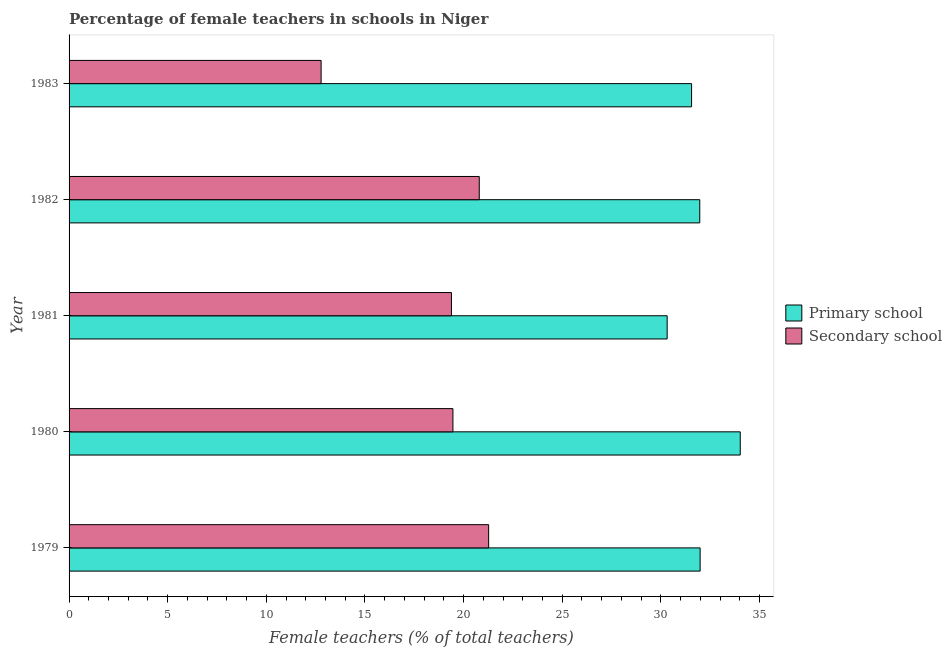How many different coloured bars are there?
Offer a very short reply. 2. How many groups of bars are there?
Make the answer very short. 5. How many bars are there on the 3rd tick from the bottom?
Your response must be concise. 2. What is the percentage of female teachers in secondary schools in 1980?
Ensure brevity in your answer.  19.46. Across all years, what is the maximum percentage of female teachers in secondary schools?
Offer a very short reply. 21.27. Across all years, what is the minimum percentage of female teachers in primary schools?
Offer a terse response. 30.32. In which year was the percentage of female teachers in primary schools maximum?
Give a very brief answer. 1980. What is the total percentage of female teachers in secondary schools in the graph?
Your response must be concise. 93.68. What is the difference between the percentage of female teachers in primary schools in 1981 and that in 1983?
Offer a very short reply. -1.24. What is the difference between the percentage of female teachers in primary schools in 1979 and the percentage of female teachers in secondary schools in 1983?
Your answer should be very brief. 19.21. What is the average percentage of female teachers in primary schools per year?
Provide a short and direct response. 31.97. In the year 1980, what is the difference between the percentage of female teachers in secondary schools and percentage of female teachers in primary schools?
Give a very brief answer. -14.56. In how many years, is the percentage of female teachers in primary schools greater than 11 %?
Make the answer very short. 5. What is the ratio of the percentage of female teachers in secondary schools in 1980 to that in 1983?
Give a very brief answer. 1.52. Is the percentage of female teachers in primary schools in 1979 less than that in 1982?
Your response must be concise. No. What is the difference between the highest and the second highest percentage of female teachers in secondary schools?
Provide a succinct answer. 0.47. What is the difference between the highest and the lowest percentage of female teachers in secondary schools?
Your response must be concise. 8.49. What does the 1st bar from the top in 1981 represents?
Keep it short and to the point. Secondary school. What does the 1st bar from the bottom in 1981 represents?
Give a very brief answer. Primary school. How many bars are there?
Keep it short and to the point. 10. What is the difference between two consecutive major ticks on the X-axis?
Offer a very short reply. 5. Does the graph contain any zero values?
Offer a very short reply. No. Does the graph contain grids?
Your answer should be compact. No. Where does the legend appear in the graph?
Offer a terse response. Center right. What is the title of the graph?
Offer a terse response. Percentage of female teachers in schools in Niger. Does "Males" appear as one of the legend labels in the graph?
Give a very brief answer. No. What is the label or title of the X-axis?
Keep it short and to the point. Female teachers (% of total teachers). What is the Female teachers (% of total teachers) in Primary school in 1979?
Provide a short and direct response. 31.99. What is the Female teachers (% of total teachers) in Secondary school in 1979?
Give a very brief answer. 21.27. What is the Female teachers (% of total teachers) of Primary school in 1980?
Provide a short and direct response. 34.02. What is the Female teachers (% of total teachers) in Secondary school in 1980?
Ensure brevity in your answer.  19.46. What is the Female teachers (% of total teachers) in Primary school in 1981?
Offer a terse response. 30.32. What is the Female teachers (% of total teachers) of Secondary school in 1981?
Your answer should be very brief. 19.38. What is the Female teachers (% of total teachers) in Primary school in 1982?
Your answer should be very brief. 31.97. What is the Female teachers (% of total teachers) in Secondary school in 1982?
Ensure brevity in your answer.  20.79. What is the Female teachers (% of total teachers) in Primary school in 1983?
Ensure brevity in your answer.  31.56. What is the Female teachers (% of total teachers) of Secondary school in 1983?
Your answer should be very brief. 12.78. Across all years, what is the maximum Female teachers (% of total teachers) in Primary school?
Make the answer very short. 34.02. Across all years, what is the maximum Female teachers (% of total teachers) in Secondary school?
Keep it short and to the point. 21.27. Across all years, what is the minimum Female teachers (% of total teachers) of Primary school?
Your answer should be compact. 30.32. Across all years, what is the minimum Female teachers (% of total teachers) of Secondary school?
Your response must be concise. 12.78. What is the total Female teachers (% of total teachers) in Primary school in the graph?
Provide a succinct answer. 159.86. What is the total Female teachers (% of total teachers) in Secondary school in the graph?
Give a very brief answer. 93.68. What is the difference between the Female teachers (% of total teachers) in Primary school in 1979 and that in 1980?
Your answer should be very brief. -2.03. What is the difference between the Female teachers (% of total teachers) in Secondary school in 1979 and that in 1980?
Offer a terse response. 1.81. What is the difference between the Female teachers (% of total teachers) in Primary school in 1979 and that in 1981?
Your answer should be compact. 1.67. What is the difference between the Female teachers (% of total teachers) of Secondary school in 1979 and that in 1981?
Your answer should be very brief. 1.88. What is the difference between the Female teachers (% of total teachers) of Primary school in 1979 and that in 1982?
Your answer should be very brief. 0.02. What is the difference between the Female teachers (% of total teachers) in Secondary school in 1979 and that in 1982?
Offer a very short reply. 0.47. What is the difference between the Female teachers (% of total teachers) in Primary school in 1979 and that in 1983?
Offer a very short reply. 0.43. What is the difference between the Female teachers (% of total teachers) of Secondary school in 1979 and that in 1983?
Ensure brevity in your answer.  8.49. What is the difference between the Female teachers (% of total teachers) of Primary school in 1980 and that in 1981?
Offer a terse response. 3.7. What is the difference between the Female teachers (% of total teachers) in Secondary school in 1980 and that in 1981?
Your answer should be compact. 0.07. What is the difference between the Female teachers (% of total teachers) of Primary school in 1980 and that in 1982?
Ensure brevity in your answer.  2.05. What is the difference between the Female teachers (% of total teachers) in Secondary school in 1980 and that in 1982?
Your answer should be very brief. -1.34. What is the difference between the Female teachers (% of total teachers) in Primary school in 1980 and that in 1983?
Your response must be concise. 2.47. What is the difference between the Female teachers (% of total teachers) of Secondary school in 1980 and that in 1983?
Your answer should be compact. 6.68. What is the difference between the Female teachers (% of total teachers) in Primary school in 1981 and that in 1982?
Provide a succinct answer. -1.65. What is the difference between the Female teachers (% of total teachers) of Secondary school in 1981 and that in 1982?
Make the answer very short. -1.41. What is the difference between the Female teachers (% of total teachers) in Primary school in 1981 and that in 1983?
Make the answer very short. -1.24. What is the difference between the Female teachers (% of total teachers) in Secondary school in 1981 and that in 1983?
Your response must be concise. 6.61. What is the difference between the Female teachers (% of total teachers) of Primary school in 1982 and that in 1983?
Ensure brevity in your answer.  0.42. What is the difference between the Female teachers (% of total teachers) of Secondary school in 1982 and that in 1983?
Provide a short and direct response. 8.02. What is the difference between the Female teachers (% of total teachers) in Primary school in 1979 and the Female teachers (% of total teachers) in Secondary school in 1980?
Make the answer very short. 12.53. What is the difference between the Female teachers (% of total teachers) in Primary school in 1979 and the Female teachers (% of total teachers) in Secondary school in 1981?
Offer a very short reply. 12.61. What is the difference between the Female teachers (% of total teachers) in Primary school in 1979 and the Female teachers (% of total teachers) in Secondary school in 1982?
Keep it short and to the point. 11.2. What is the difference between the Female teachers (% of total teachers) in Primary school in 1979 and the Female teachers (% of total teachers) in Secondary school in 1983?
Keep it short and to the point. 19.21. What is the difference between the Female teachers (% of total teachers) in Primary school in 1980 and the Female teachers (% of total teachers) in Secondary school in 1981?
Provide a succinct answer. 14.64. What is the difference between the Female teachers (% of total teachers) in Primary school in 1980 and the Female teachers (% of total teachers) in Secondary school in 1982?
Your answer should be very brief. 13.23. What is the difference between the Female teachers (% of total teachers) of Primary school in 1980 and the Female teachers (% of total teachers) of Secondary school in 1983?
Your answer should be very brief. 21.25. What is the difference between the Female teachers (% of total teachers) in Primary school in 1981 and the Female teachers (% of total teachers) in Secondary school in 1982?
Make the answer very short. 9.52. What is the difference between the Female teachers (% of total teachers) in Primary school in 1981 and the Female teachers (% of total teachers) in Secondary school in 1983?
Ensure brevity in your answer.  17.54. What is the difference between the Female teachers (% of total teachers) in Primary school in 1982 and the Female teachers (% of total teachers) in Secondary school in 1983?
Offer a very short reply. 19.2. What is the average Female teachers (% of total teachers) of Primary school per year?
Give a very brief answer. 31.97. What is the average Female teachers (% of total teachers) of Secondary school per year?
Your response must be concise. 18.74. In the year 1979, what is the difference between the Female teachers (% of total teachers) in Primary school and Female teachers (% of total teachers) in Secondary school?
Offer a very short reply. 10.72. In the year 1980, what is the difference between the Female teachers (% of total teachers) of Primary school and Female teachers (% of total teachers) of Secondary school?
Keep it short and to the point. 14.56. In the year 1981, what is the difference between the Female teachers (% of total teachers) of Primary school and Female teachers (% of total teachers) of Secondary school?
Your response must be concise. 10.93. In the year 1982, what is the difference between the Female teachers (% of total teachers) in Primary school and Female teachers (% of total teachers) in Secondary school?
Your answer should be compact. 11.18. In the year 1983, what is the difference between the Female teachers (% of total teachers) of Primary school and Female teachers (% of total teachers) of Secondary school?
Make the answer very short. 18.78. What is the ratio of the Female teachers (% of total teachers) of Primary school in 1979 to that in 1980?
Keep it short and to the point. 0.94. What is the ratio of the Female teachers (% of total teachers) in Secondary school in 1979 to that in 1980?
Your answer should be very brief. 1.09. What is the ratio of the Female teachers (% of total teachers) in Primary school in 1979 to that in 1981?
Ensure brevity in your answer.  1.06. What is the ratio of the Female teachers (% of total teachers) of Secondary school in 1979 to that in 1981?
Give a very brief answer. 1.1. What is the ratio of the Female teachers (% of total teachers) in Secondary school in 1979 to that in 1982?
Your answer should be compact. 1.02. What is the ratio of the Female teachers (% of total teachers) in Primary school in 1979 to that in 1983?
Your answer should be very brief. 1.01. What is the ratio of the Female teachers (% of total teachers) of Secondary school in 1979 to that in 1983?
Offer a very short reply. 1.66. What is the ratio of the Female teachers (% of total teachers) in Primary school in 1980 to that in 1981?
Provide a short and direct response. 1.12. What is the ratio of the Female teachers (% of total teachers) of Secondary school in 1980 to that in 1981?
Your answer should be compact. 1. What is the ratio of the Female teachers (% of total teachers) of Primary school in 1980 to that in 1982?
Your answer should be very brief. 1.06. What is the ratio of the Female teachers (% of total teachers) in Secondary school in 1980 to that in 1982?
Your response must be concise. 0.94. What is the ratio of the Female teachers (% of total teachers) of Primary school in 1980 to that in 1983?
Give a very brief answer. 1.08. What is the ratio of the Female teachers (% of total teachers) of Secondary school in 1980 to that in 1983?
Your answer should be compact. 1.52. What is the ratio of the Female teachers (% of total teachers) in Primary school in 1981 to that in 1982?
Offer a very short reply. 0.95. What is the ratio of the Female teachers (% of total teachers) in Secondary school in 1981 to that in 1982?
Give a very brief answer. 0.93. What is the ratio of the Female teachers (% of total teachers) of Primary school in 1981 to that in 1983?
Your response must be concise. 0.96. What is the ratio of the Female teachers (% of total teachers) of Secondary school in 1981 to that in 1983?
Offer a very short reply. 1.52. What is the ratio of the Female teachers (% of total teachers) of Primary school in 1982 to that in 1983?
Keep it short and to the point. 1.01. What is the ratio of the Female teachers (% of total teachers) of Secondary school in 1982 to that in 1983?
Keep it short and to the point. 1.63. What is the difference between the highest and the second highest Female teachers (% of total teachers) in Primary school?
Your response must be concise. 2.03. What is the difference between the highest and the second highest Female teachers (% of total teachers) of Secondary school?
Keep it short and to the point. 0.47. What is the difference between the highest and the lowest Female teachers (% of total teachers) of Primary school?
Provide a succinct answer. 3.7. What is the difference between the highest and the lowest Female teachers (% of total teachers) of Secondary school?
Give a very brief answer. 8.49. 